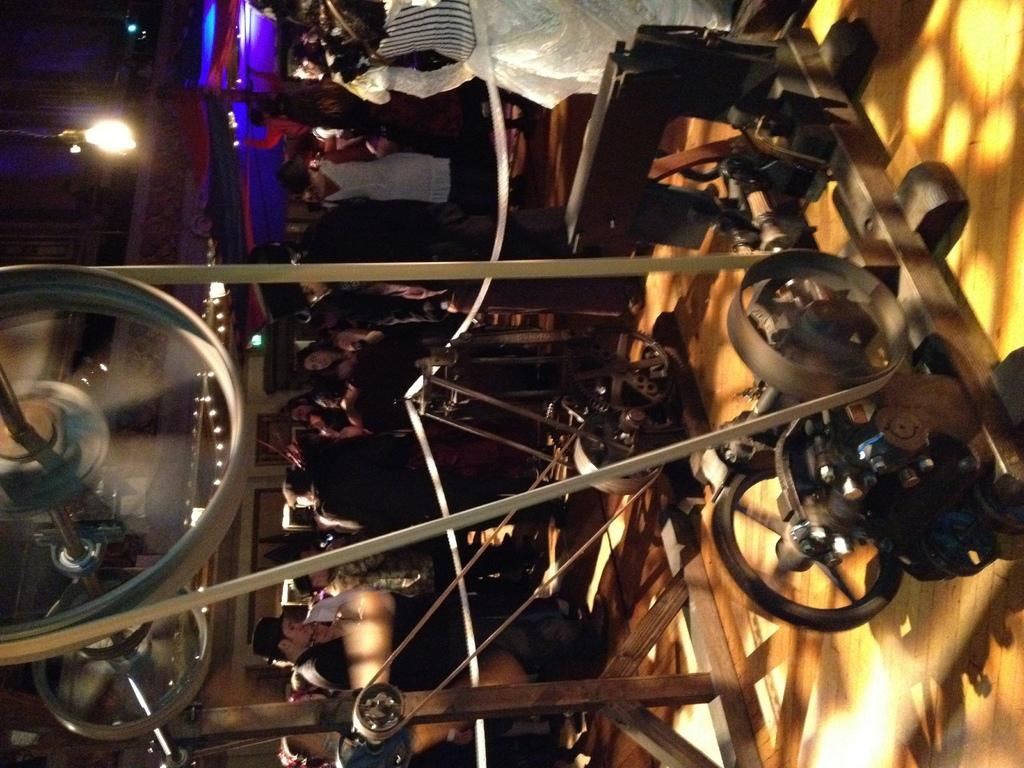What is the main subject in the center of the image? There is a machine in the center of the image. What are the people in the background doing? The people in the background are dancing and standing. Where are the lights located in the image? The lights are on the left side of the image. What can be seen on the right side of the image? There is a floor visible on the right side of the image. What type of wound is visible on the dancer's leg in the image? There is no dancer or wound present in the image; it features a machine and people standing or dancing in the background. 